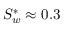Convert formula to latex. <formula><loc_0><loc_0><loc_500><loc_500>S _ { w } ^ { * } \approx 0 . 3</formula> 